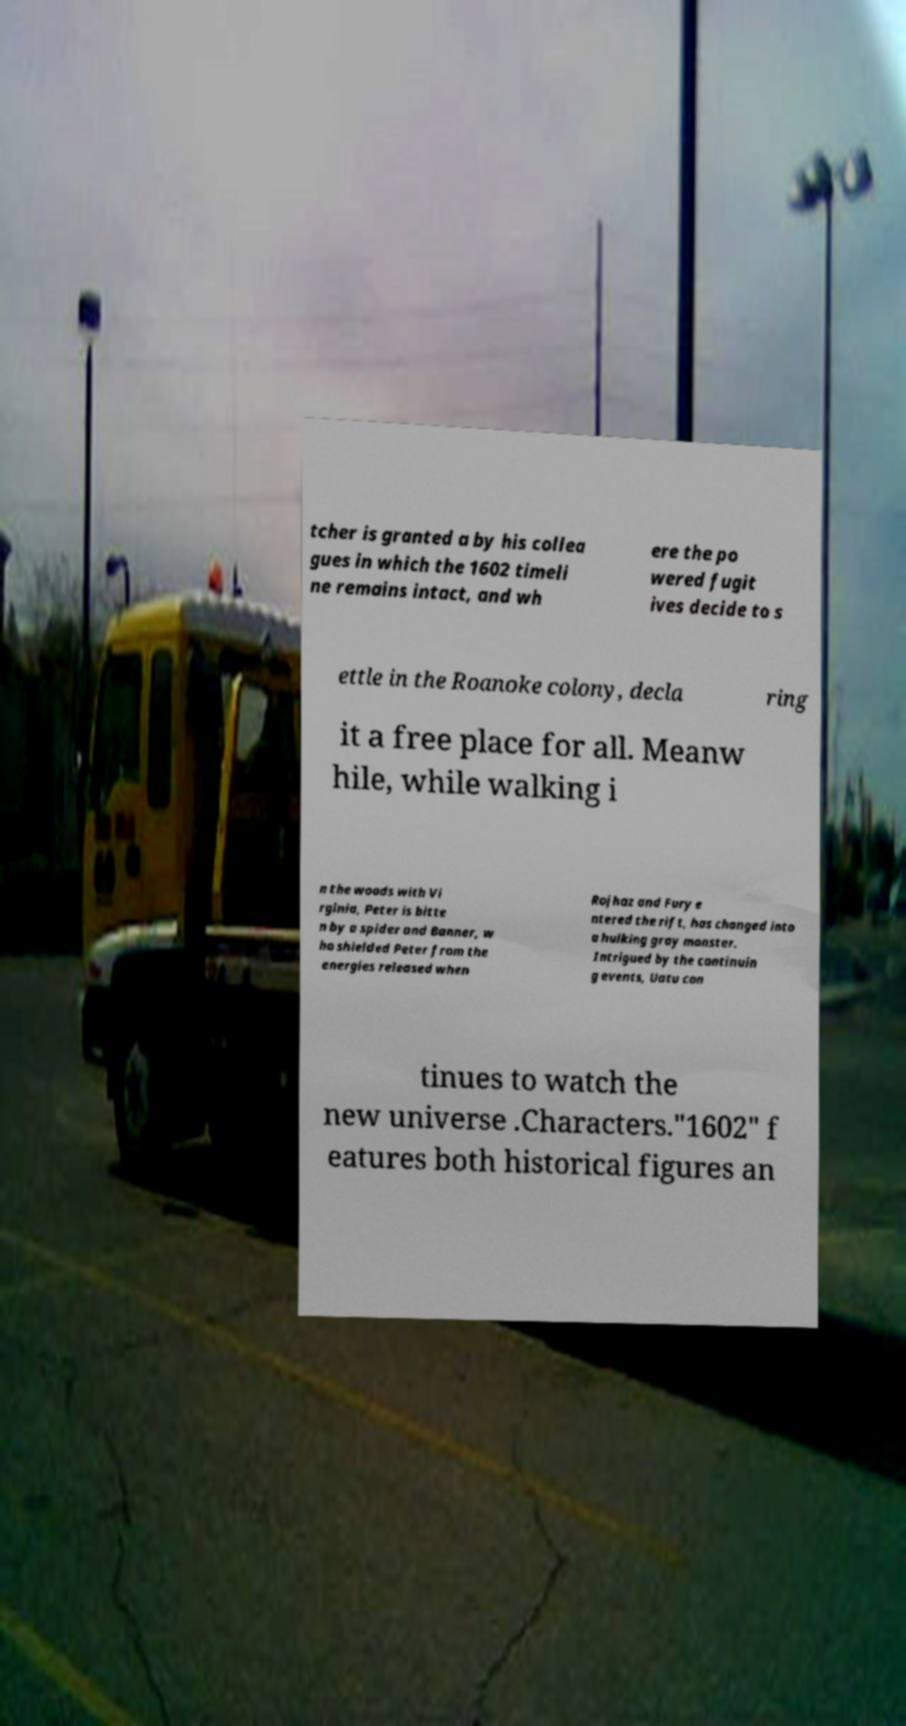Could you assist in decoding the text presented in this image and type it out clearly? tcher is granted a by his collea gues in which the 1602 timeli ne remains intact, and wh ere the po wered fugit ives decide to s ettle in the Roanoke colony, decla ring it a free place for all. Meanw hile, while walking i n the woods with Vi rginia, Peter is bitte n by a spider and Banner, w ho shielded Peter from the energies released when Rojhaz and Fury e ntered the rift, has changed into a hulking gray monster. Intrigued by the continuin g events, Uatu con tinues to watch the new universe .Characters."1602" f eatures both historical figures an 